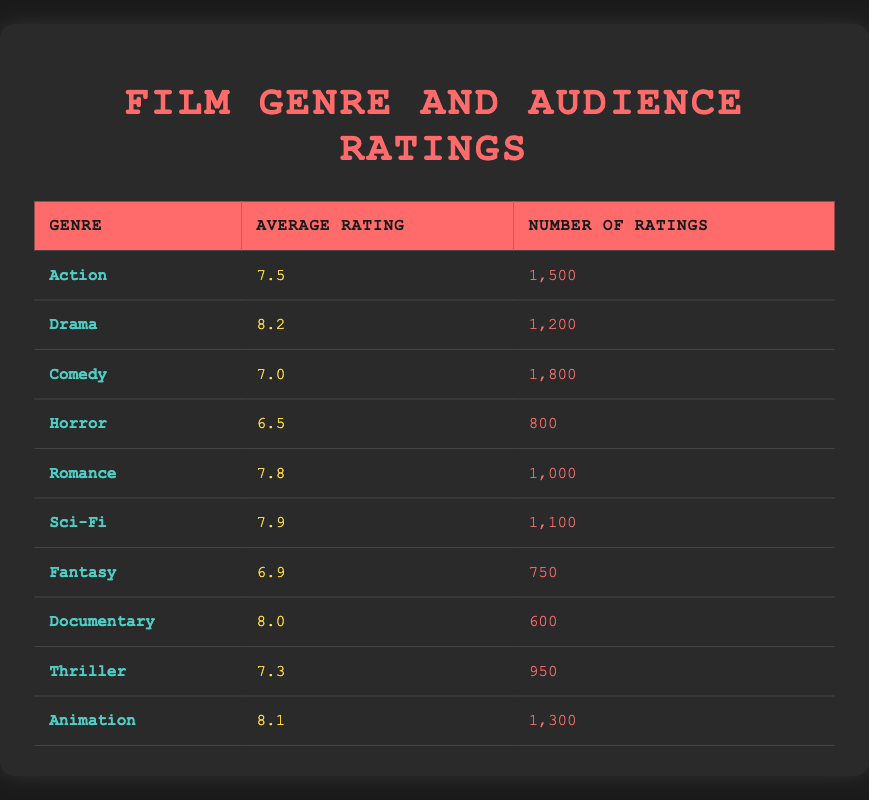What's the average rating for the Action genre? The average rating for the Action genre is listed directly in the table under "Average Rating." It shows 7.5
Answer: 7.5 Which genre has the highest average rating? By comparing the "Average Rating" column for each genre, I see that Drama has the highest value at 8.2
Answer: Drama How many ratings does the Comedy genre have? The number of ratings for the Comedy genre can be found under "Number of Ratings," where it shows 1,800
Answer: 1,800 Is there a genre with an average rating below 7? Looking through the "Average Rating" column, Horror has the lowest value at 6.5, which is indeed below 7
Answer: Yes What is the difference in average ratings between the highest and lowest-rated genres? The highest average rating is for Drama at 8.2, while the lowest is for Horror at 6.5. The difference is calculated as 8.2 - 6.5 = 1.7
Answer: 1.7 Which genre has more ratings, Animation or Documentary? Animation has 1,300 ratings, while Documentary has 600 ratings, so Animation has more ratings. This can be confirmed by comparing the "Number of Ratings" column
Answer: Animation What is the average of the average ratings for Sci-Fi, Thriller, and Romance? To find the average, first sum the average ratings: Sci-Fi (7.9) + Thriller (7.3) + Romance (7.8) = 23.0, then divide by 3, which gives 23.0 / 3 = 7.67
Answer: 7.67 Are there more total ratings for Action and Drama combined than for Horror and Fantasy combined? The total ratings for Action (1,500) and Drama (1,200) is 2,700 while for Horror (800) and Fantasy (750) it is 1,550. Since 2,700 is greater than 1,550, the statement is true
Answer: Yes What percentage of ratings does the Humor genre have out of the total ratings from all genres listed? As Humor is not listed, we will calculate from existing genres. The total ratings for all genres is 1,500 + 1,200 + 1,800 + 800 + 1,000 + 1,100 + 750 + 600 + 950 + 1,300 = 11,000. Since Humor is not included, its percentage is 0/11000 = 0%. This shows that there is no Humor genre present
Answer: 0% 